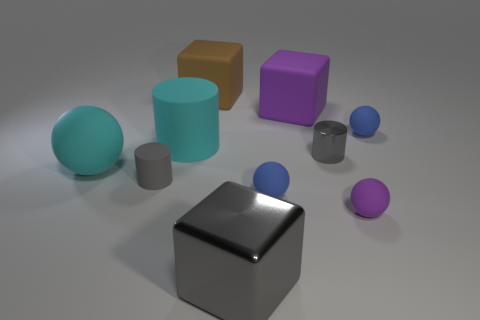Subtract all cubes. How many objects are left? 7 Add 1 small balls. How many small balls exist? 4 Subtract 0 cyan blocks. How many objects are left? 10 Subtract all big metal blocks. Subtract all large gray metallic objects. How many objects are left? 8 Add 8 small blue rubber objects. How many small blue rubber objects are left? 10 